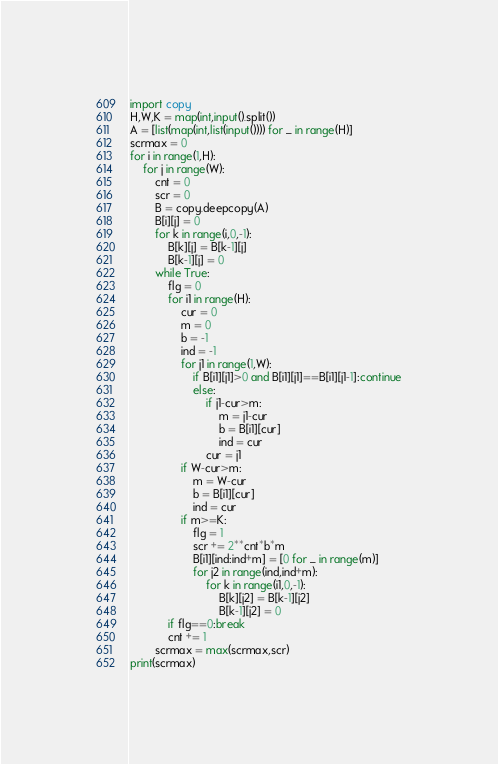Convert code to text. <code><loc_0><loc_0><loc_500><loc_500><_Python_>import copy
H,W,K = map(int,input().split())
A = [list(map(int,list(input()))) for _ in range(H)]
scrmax = 0
for i in range(1,H):
    for j in range(W):
        cnt = 0
        scr = 0
        B = copy.deepcopy(A)
        B[i][j] = 0
        for k in range(i,0,-1):
            B[k][j] = B[k-1][j]
            B[k-1][j] = 0
        while True:
            flg = 0
            for i1 in range(H):
                cur = 0
                m = 0
                b = -1
                ind = -1
                for j1 in range(1,W):
                    if B[i1][j1]>0 and B[i1][j1]==B[i1][j1-1]:continue
                    else:
                        if j1-cur>m:
                            m = j1-cur
                            b = B[i1][cur]
                            ind = cur
                        cur = j1
                if W-cur>m:
                    m = W-cur
                    b = B[i1][cur]
                    ind = cur
                if m>=K:
                    flg = 1
                    scr += 2**cnt*b*m
                    B[i1][ind:ind+m] = [0 for _ in range(m)]
                    for j2 in range(ind,ind+m):
                        for k in range(i1,0,-1):
                            B[k][j2] = B[k-1][j2]
                            B[k-1][j2] = 0
            if flg==0:break
            cnt += 1
        scrmax = max(scrmax,scr)     
print(scrmax)</code> 